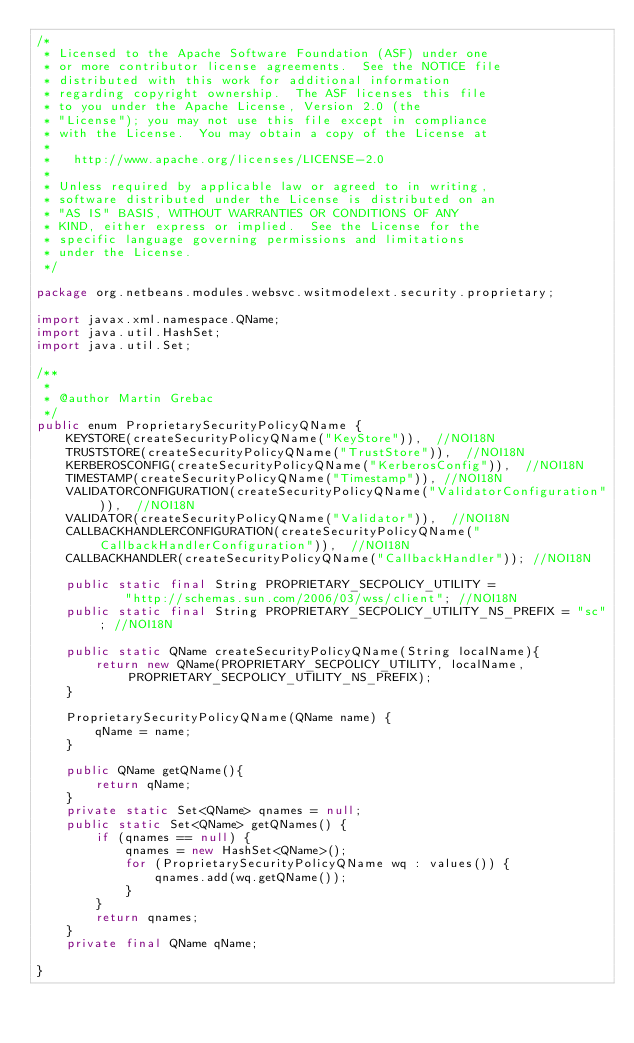<code> <loc_0><loc_0><loc_500><loc_500><_Java_>/*
 * Licensed to the Apache Software Foundation (ASF) under one
 * or more contributor license agreements.  See the NOTICE file
 * distributed with this work for additional information
 * regarding copyright ownership.  The ASF licenses this file
 * to you under the Apache License, Version 2.0 (the
 * "License"); you may not use this file except in compliance
 * with the License.  You may obtain a copy of the License at
 *
 *   http://www.apache.org/licenses/LICENSE-2.0
 *
 * Unless required by applicable law or agreed to in writing,
 * software distributed under the License is distributed on an
 * "AS IS" BASIS, WITHOUT WARRANTIES OR CONDITIONS OF ANY
 * KIND, either express or implied.  See the License for the
 * specific language governing permissions and limitations
 * under the License.
 */

package org.netbeans.modules.websvc.wsitmodelext.security.proprietary;

import javax.xml.namespace.QName;
import java.util.HashSet;
import java.util.Set;

/**
 *
 * @author Martin Grebac
 */
public enum ProprietarySecurityPolicyQName {
    KEYSTORE(createSecurityPolicyQName("KeyStore")),  //NOI18N
    TRUSTSTORE(createSecurityPolicyQName("TrustStore")),  //NOI18N
    KERBEROSCONFIG(createSecurityPolicyQName("KerberosConfig")),  //NOI18N
    TIMESTAMP(createSecurityPolicyQName("Timestamp")), //NOI18N
    VALIDATORCONFIGURATION(createSecurityPolicyQName("ValidatorConfiguration")),  //NOI18N
    VALIDATOR(createSecurityPolicyQName("Validator")),  //NOI18N
    CALLBACKHANDLERCONFIGURATION(createSecurityPolicyQName("CallbackHandlerConfiguration")),  //NOI18N
    CALLBACKHANDLER(createSecurityPolicyQName("CallbackHandler")); //NOI18N

    public static final String PROPRIETARY_SECPOLICY_UTILITY = 
            "http://schemas.sun.com/2006/03/wss/client"; //NOI18N
    public static final String PROPRIETARY_SECPOLICY_UTILITY_NS_PREFIX = "sc"; //NOI18N
            
    public static QName createSecurityPolicyQName(String localName){
        return new QName(PROPRIETARY_SECPOLICY_UTILITY, localName, PROPRIETARY_SECPOLICY_UTILITY_NS_PREFIX);
    }
    
    ProprietarySecurityPolicyQName(QName name) {
        qName = name;
    }
    
    public QName getQName(){
        return qName;
    }
    private static Set<QName> qnames = null;
    public static Set<QName> getQNames() {
        if (qnames == null) {
            qnames = new HashSet<QName>();
            for (ProprietarySecurityPolicyQName wq : values()) {
                qnames.add(wq.getQName());
            }
        }
        return qnames;
    }
    private final QName qName;

}
</code> 